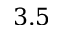<formula> <loc_0><loc_0><loc_500><loc_500>3 . 5</formula> 